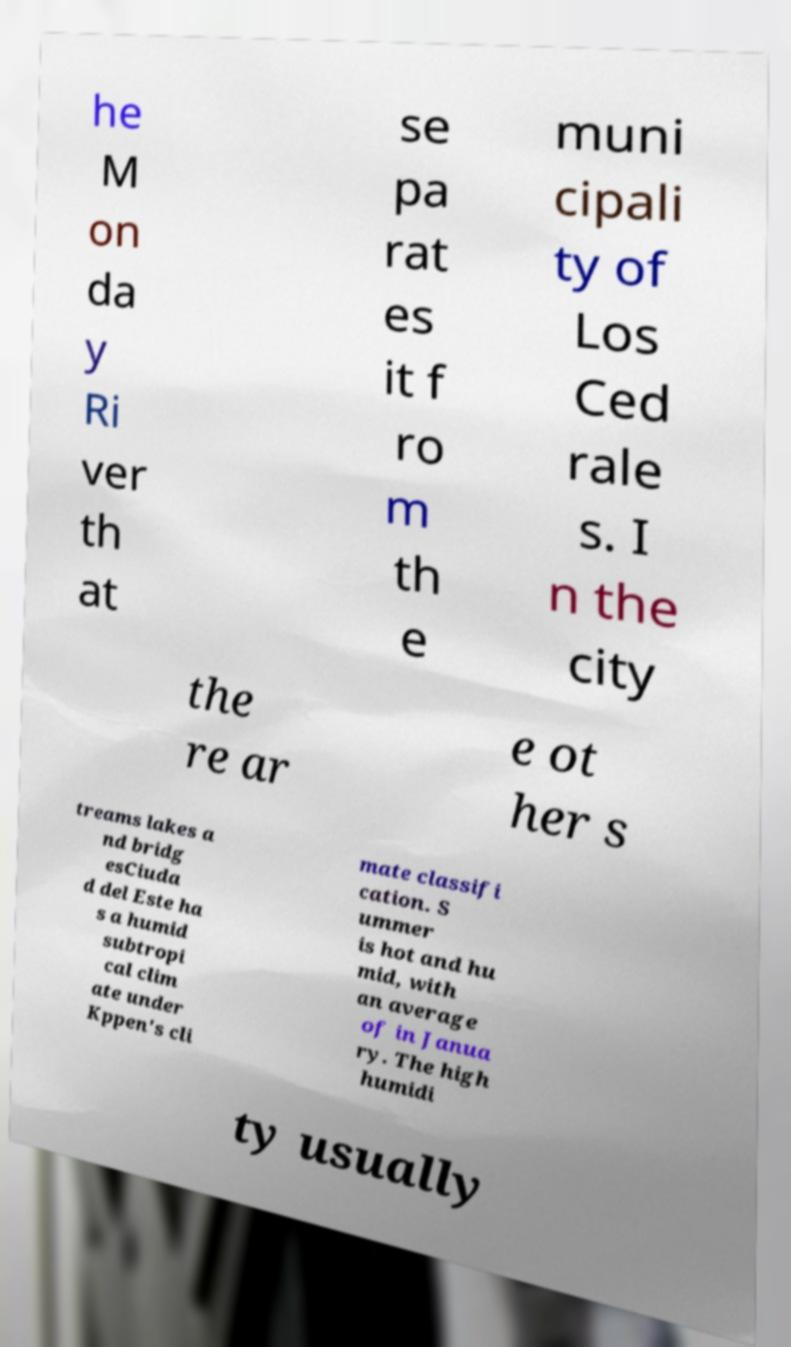There's text embedded in this image that I need extracted. Can you transcribe it verbatim? he M on da y Ri ver th at se pa rat es it f ro m th e muni cipali ty of Los Ced rale s. I n the city the re ar e ot her s treams lakes a nd bridg esCiuda d del Este ha s a humid subtropi cal clim ate under Kppen's cli mate classifi cation. S ummer is hot and hu mid, with an average of in Janua ry. The high humidi ty usually 